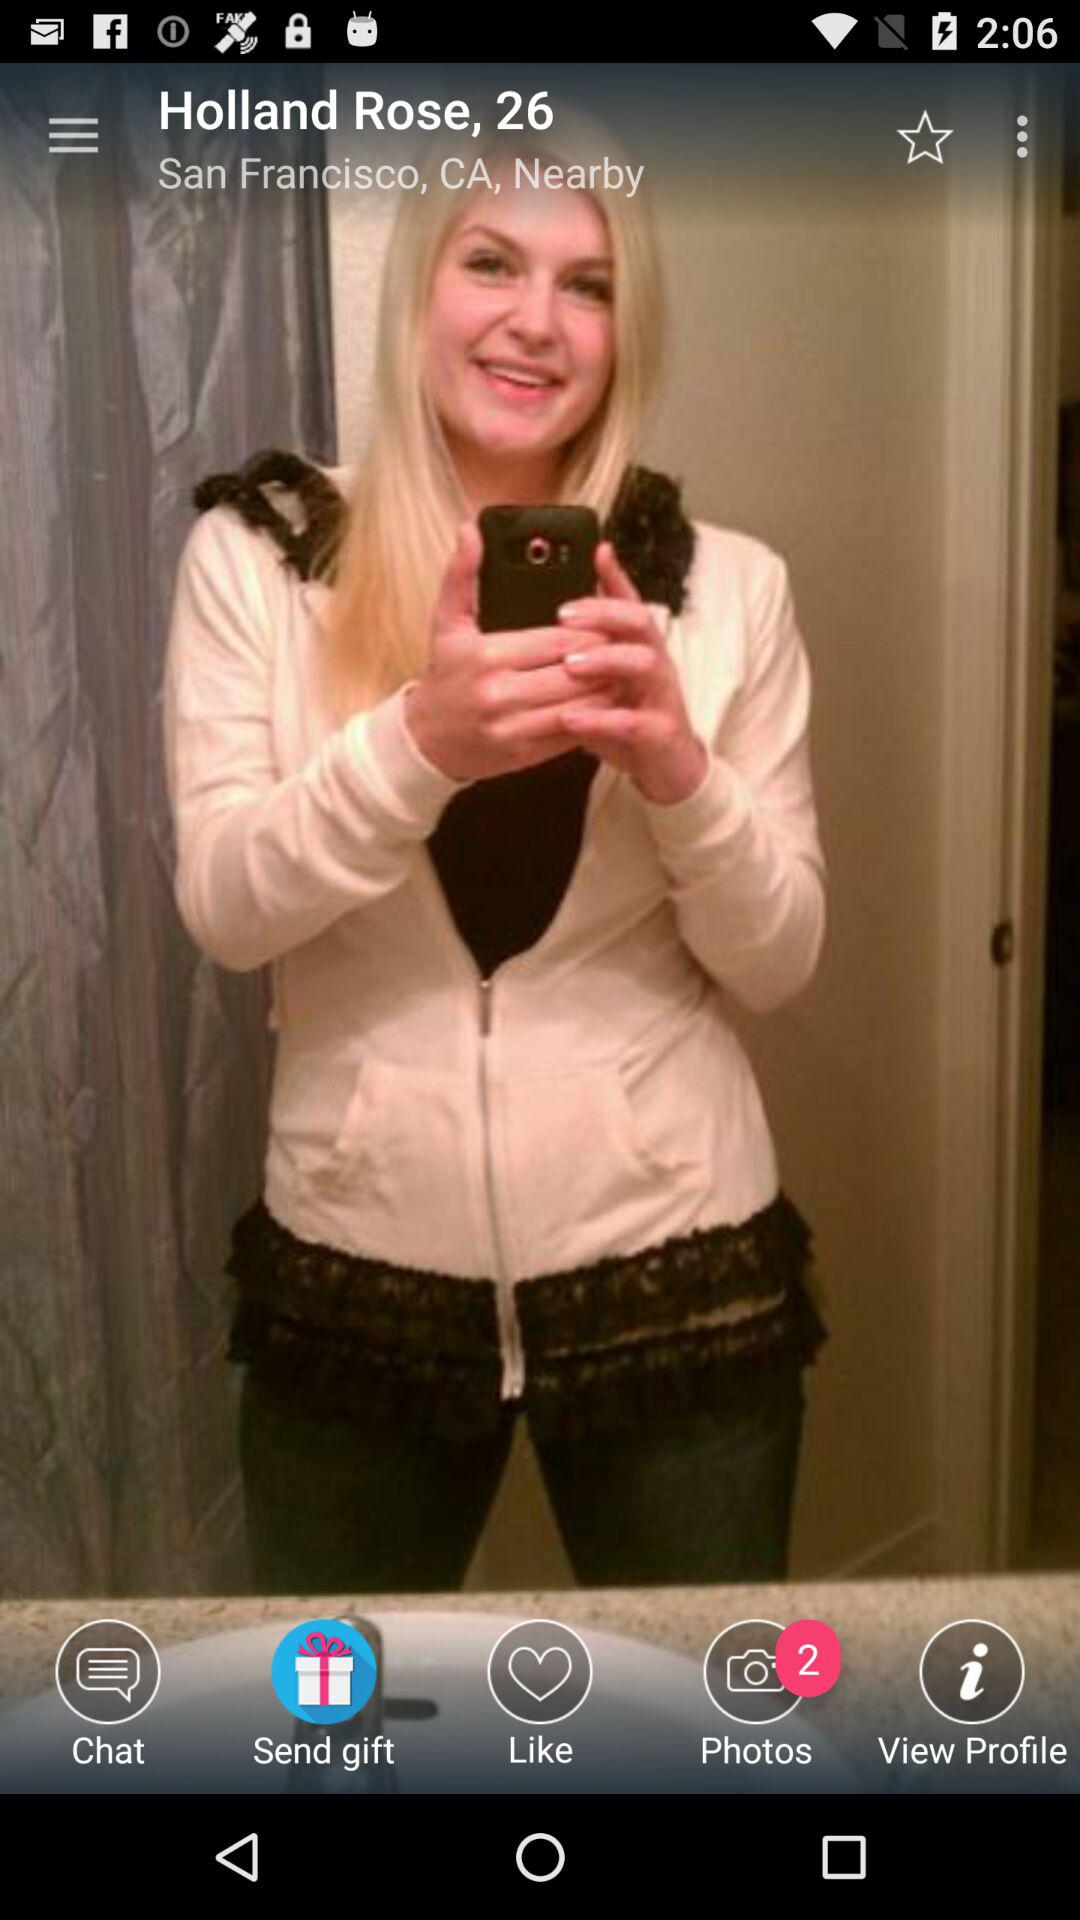What is the number of new photos? The number of new photos is 2. 